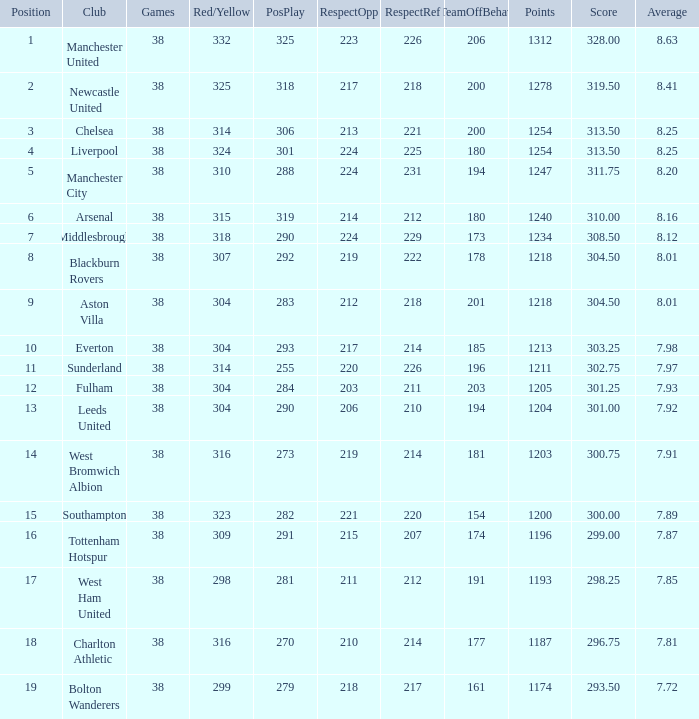Who is the most successful player for west bromwich albion club? 14.0. 